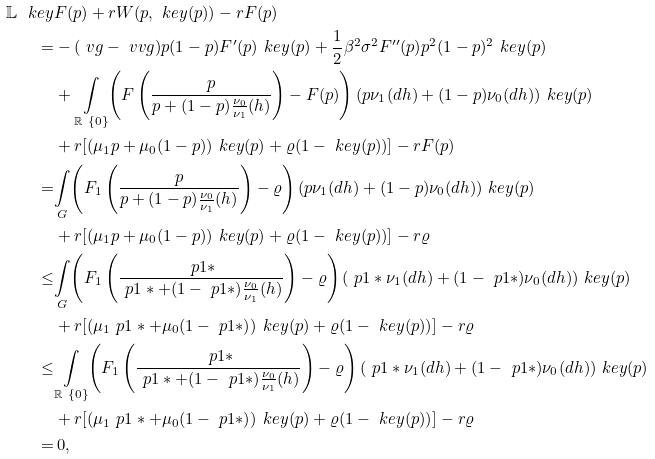Convert formula to latex. <formula><loc_0><loc_0><loc_500><loc_500>\mathbb { L } ^ { \ } k e y & F ( p ) + r W ( p , \ k e y ( p ) ) - r F ( p ) \\ = & - ( \ v g - \ v v g ) p ( 1 - p ) F ^ { \prime } ( p ) \ k e y ( p ) + \frac { 1 } { 2 } \beta ^ { 2 } \sigma ^ { 2 } F ^ { \prime \prime } ( p ) p ^ { 2 } ( 1 - p ) ^ { 2 } \ k e y ( p ) \\ & + \underset { \mathbb { R } \ \{ 0 \} } { \int } { \left ( F \left ( \frac { p } { p + ( 1 - p ) \frac { \nu _ { 0 } } { \nu _ { 1 } } ( h ) } \right ) - F ( p ) \right ) ( p \nu _ { 1 } ( d h ) + ( 1 - p ) \nu _ { 0 } ( d h ) ) \ k e y ( p ) } \\ & + r [ ( \mu _ { 1 } p + \mu _ { 0 } ( 1 - p ) ) \ k e y ( p ) + \varrho ( 1 - \ k e y ( p ) ) ] - r F ( p ) \\ = & \underset { G } { \int } { \left ( F _ { 1 } \left ( \frac { p } { p + ( 1 - p ) \frac { \nu _ { 0 } } { \nu _ { 1 } } ( h ) } \right ) - \varrho \right ) ( p \nu _ { 1 } ( d h ) + ( 1 - p ) \nu _ { 0 } ( d h ) ) \ k e y ( p ) } \\ & + r [ ( \mu _ { 1 } p + \mu _ { 0 } ( 1 - p ) ) \ k e y ( p ) + \varrho ( 1 - \ k e y ( p ) ) ] - r \varrho \\ \leq & \underset { G } { \int } { \left ( F _ { 1 } \left ( \frac { \ p 1 * } { \ p 1 * + ( 1 - \ p 1 * ) \frac { \nu _ { 0 } } { \nu _ { 1 } } ( h ) } \right ) - \varrho \right ) ( \ p 1 * \nu _ { 1 } ( d h ) + ( 1 - \ p 1 * ) \nu _ { 0 } ( d h ) ) \ k e y ( p ) } \\ & + r [ ( \mu _ { 1 } \ p 1 * + \mu _ { 0 } ( 1 - \ p 1 * ) ) \ k e y ( p ) + \varrho ( 1 - \ k e y ( p ) ) ] - r \varrho \\ \leq & \underset { \mathbb { R } \ \{ 0 \} } { \int } { \left ( F _ { 1 } \left ( \frac { \ p 1 * } { \ p 1 * + ( 1 - \ p 1 * ) \frac { \nu _ { 0 } } { \nu _ { 1 } } ( h ) } \right ) - \varrho \right ) ( \ p 1 * \nu _ { 1 } ( d h ) + ( 1 - \ p 1 * ) \nu _ { 0 } ( d h ) ) \ k e y ( p ) } \\ & + r [ ( \mu _ { 1 } \ p 1 * + \mu _ { 0 } ( 1 - \ p 1 * ) ) \ k e y ( p ) + \varrho ( 1 - \ k e y ( p ) ) ] - r \varrho \\ = & \, 0 ,</formula> 